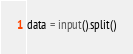Convert code to text. <code><loc_0><loc_0><loc_500><loc_500><_Python_>data = input().split()</code> 